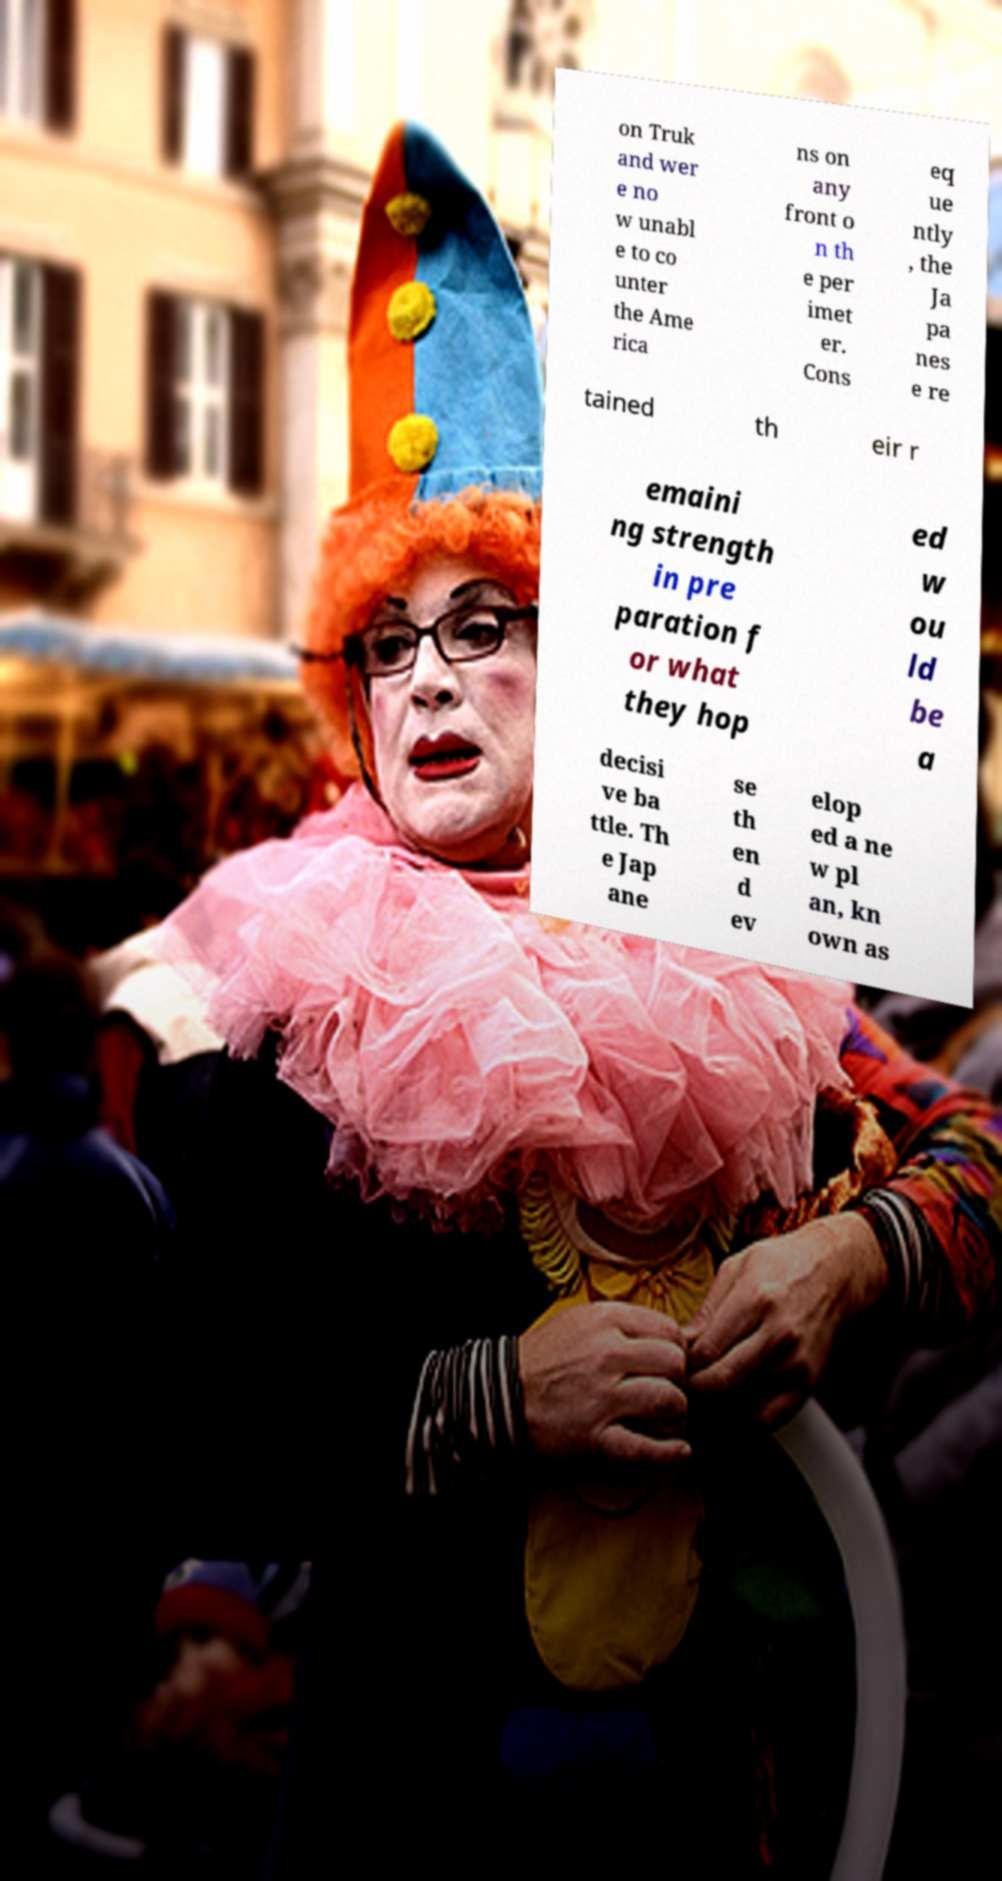Could you assist in decoding the text presented in this image and type it out clearly? on Truk and wer e no w unabl e to co unter the Ame rica ns on any front o n th e per imet er. Cons eq ue ntly , the Ja pa nes e re tained th eir r emaini ng strength in pre paration f or what they hop ed w ou ld be a decisi ve ba ttle. Th e Jap ane se th en d ev elop ed a ne w pl an, kn own as 